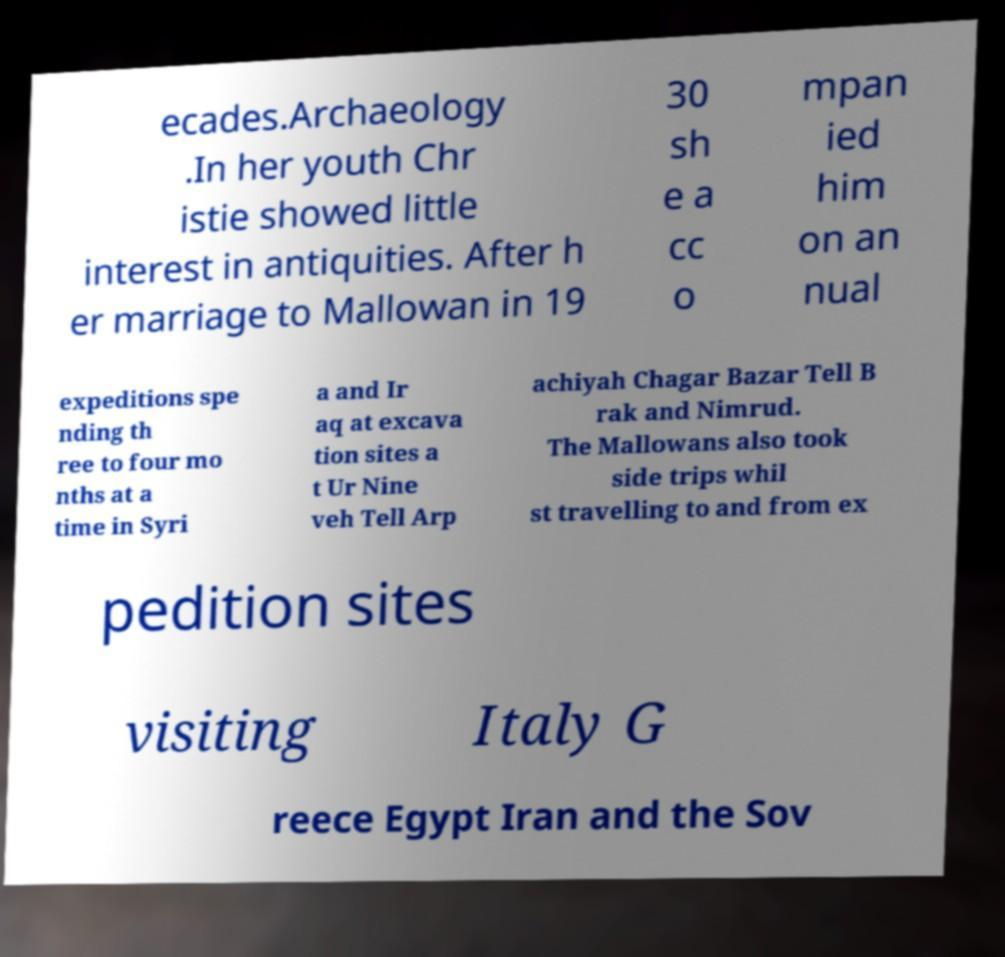Can you accurately transcribe the text from the provided image for me? ecades.Archaeology .In her youth Chr istie showed little interest in antiquities. After h er marriage to Mallowan in 19 30 sh e a cc o mpan ied him on an nual expeditions spe nding th ree to four mo nths at a time in Syri a and Ir aq at excava tion sites a t Ur Nine veh Tell Arp achiyah Chagar Bazar Tell B rak and Nimrud. The Mallowans also took side trips whil st travelling to and from ex pedition sites visiting Italy G reece Egypt Iran and the Sov 